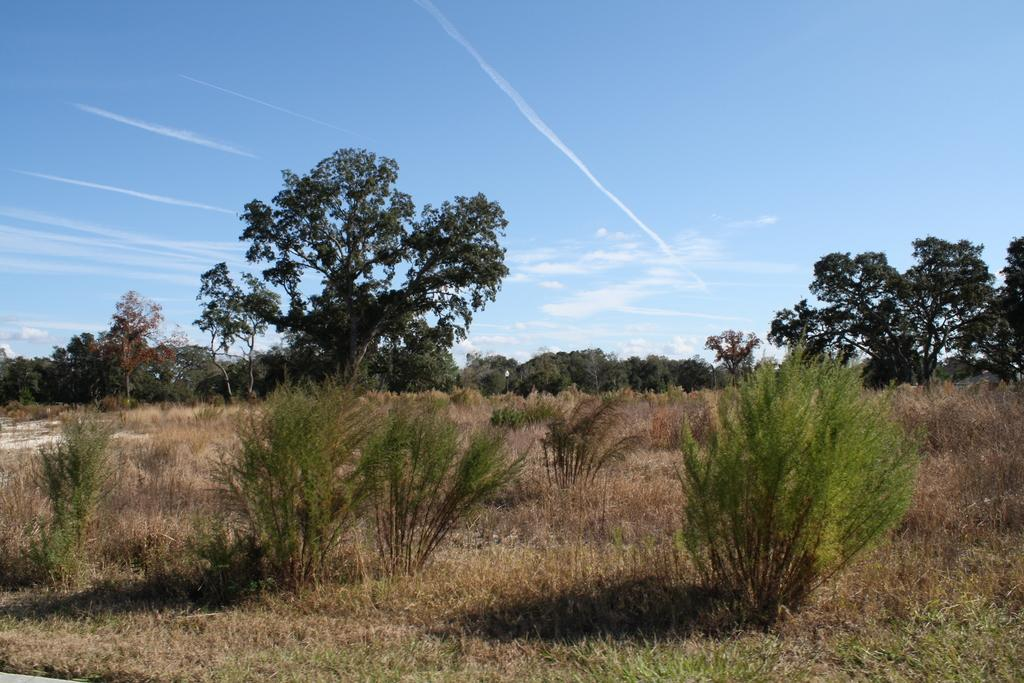What type of vegetation can be seen in the image? There are plants and trees in the image. What color are the plants and trees in the image? The plants and trees are green in color. What is visible in the background of the image? The sky is visible in the background of the image. What colors can be seen in the sky in the image? The sky is blue and white in color. Is there a cave visible in the image? There is no cave present in the image. What does the front of the cave look like in the image? Since there is no cave in the image, it is not possible to describe the front of the cave. 